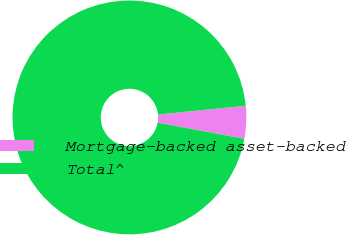<chart> <loc_0><loc_0><loc_500><loc_500><pie_chart><fcel>Mortgage-backed asset-backed<fcel>Total^<nl><fcel>4.53%<fcel>95.47%<nl></chart> 